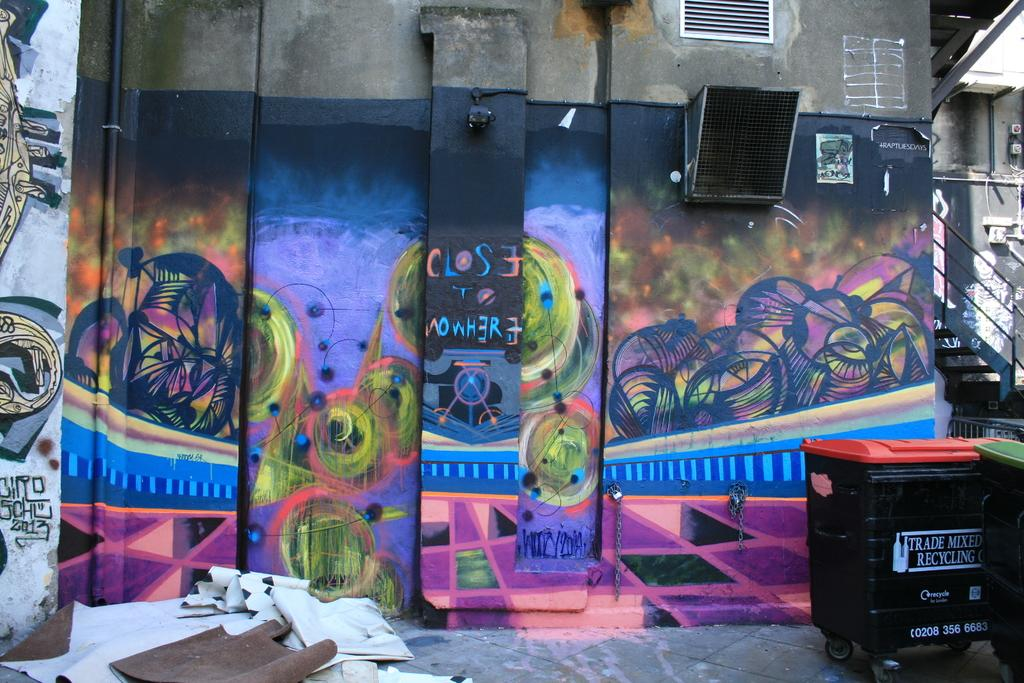Provide a one-sentence caption for the provided image. A trade mixed recycling bin sits behind a shop that has been covered in mostly purple graffiti. 